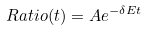Convert formula to latex. <formula><loc_0><loc_0><loc_500><loc_500>R a t i o ( t ) = A e ^ { - \delta E t }</formula> 